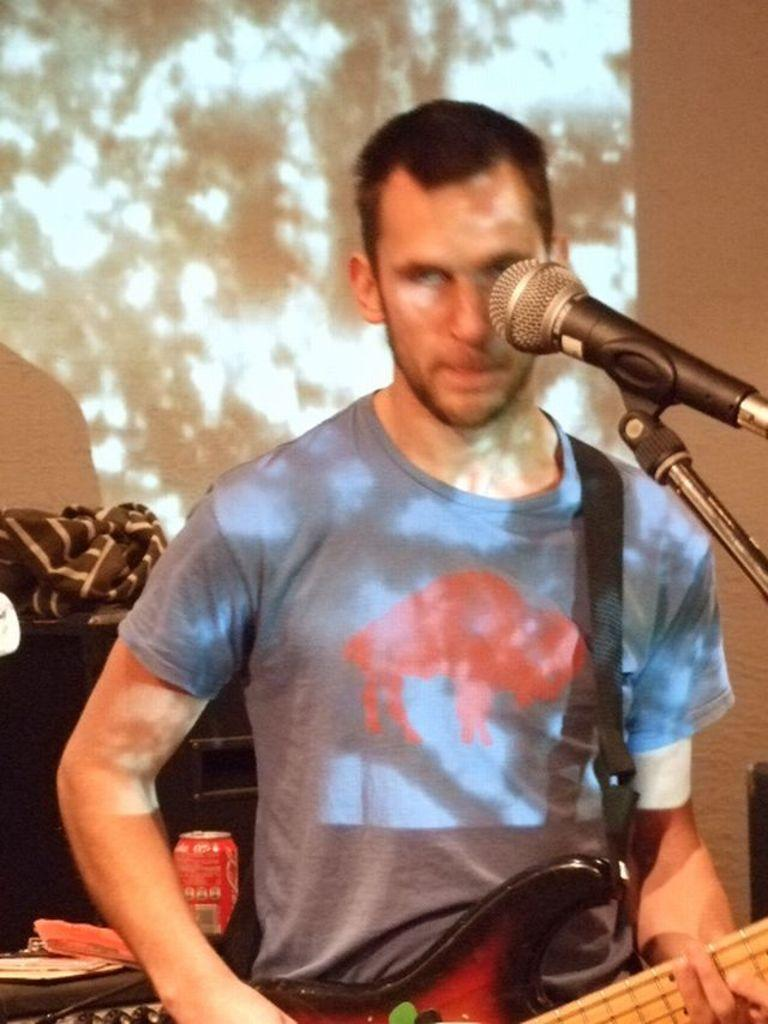Who is the main subject in the image? There is a man in the image. What is the man doing in the image? The man is standing in front of a microphone and playing a guitar. What can be seen in the background of the image? There is a screen in the background of the image. What type of trousers is the man wearing in the image? The provided facts do not mention the type of trousers the man is wearing, so it cannot be determined from the image. 